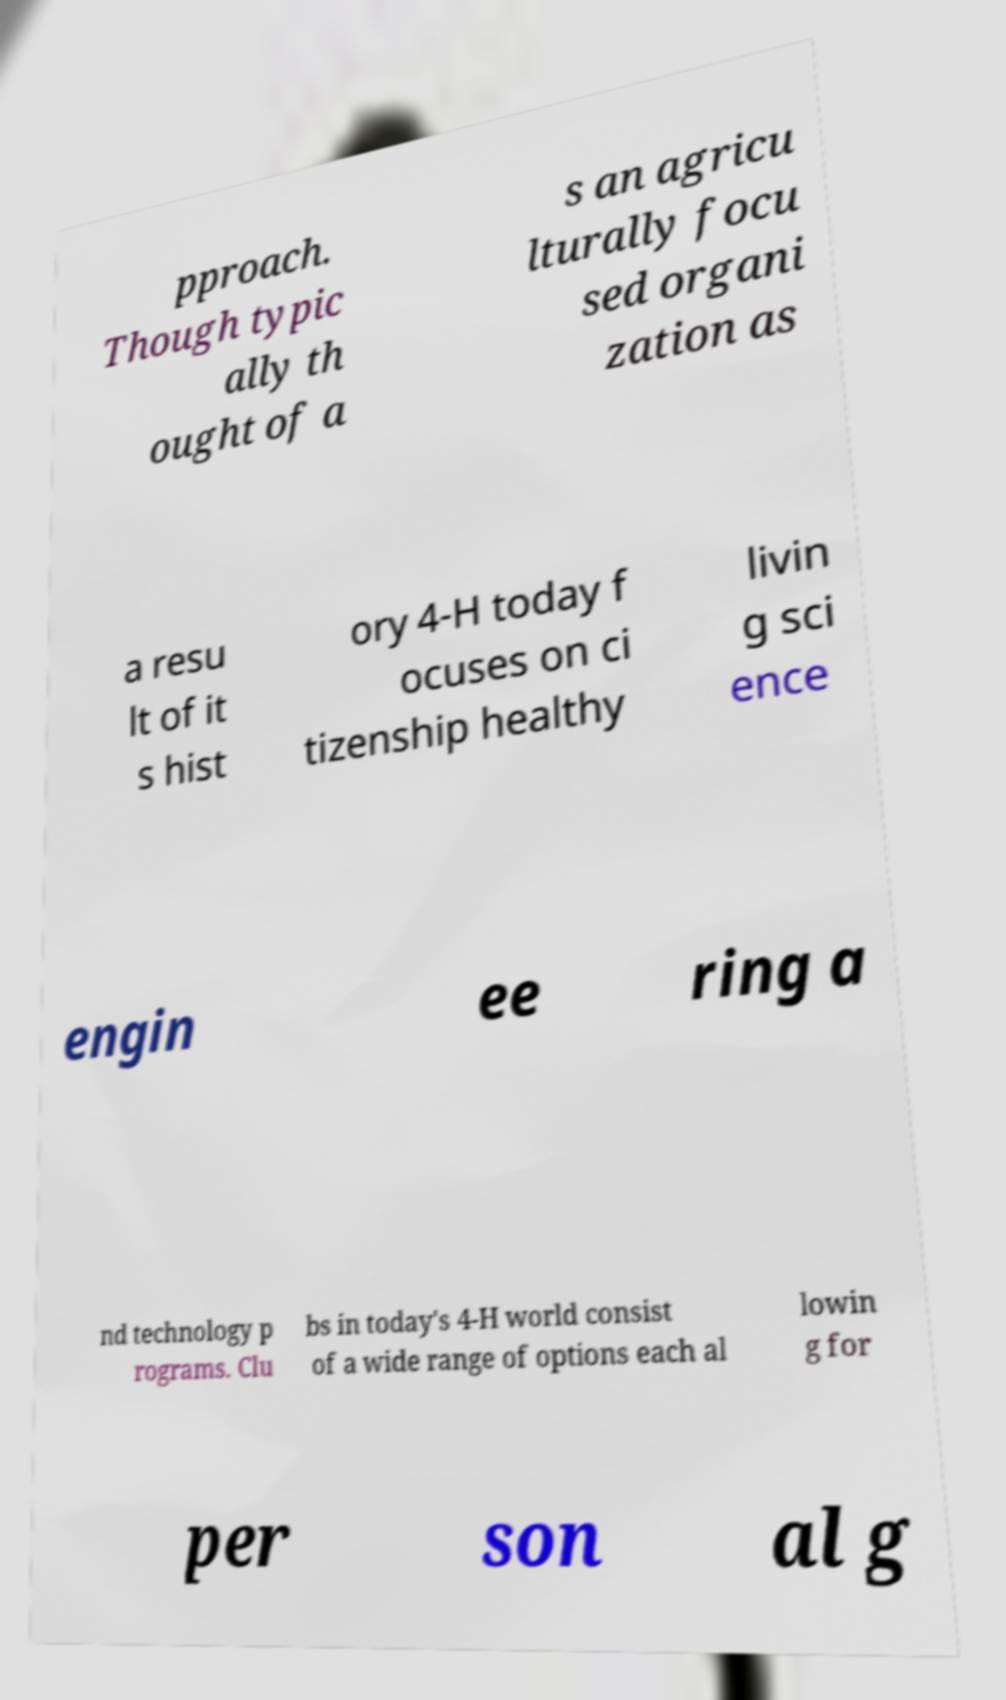Can you read and provide the text displayed in the image?This photo seems to have some interesting text. Can you extract and type it out for me? pproach. Though typic ally th ought of a s an agricu lturally focu sed organi zation as a resu lt of it s hist ory 4-H today f ocuses on ci tizenship healthy livin g sci ence engin ee ring a nd technology p rograms. Clu bs in today's 4-H world consist of a wide range of options each al lowin g for per son al g 